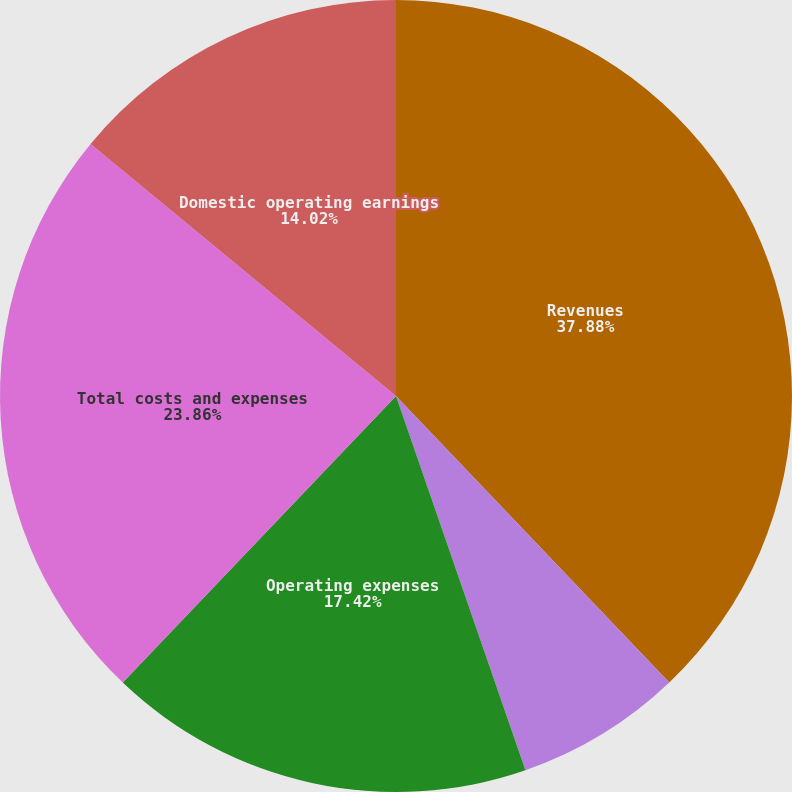Convert chart. <chart><loc_0><loc_0><loc_500><loc_500><pie_chart><fcel>Revenues<fcel>Costs of revenue<fcel>Operating expenses<fcel>Total costs and expenses<fcel>Domestic operating earnings<nl><fcel>37.88%<fcel>6.82%<fcel>17.42%<fcel>23.86%<fcel>14.02%<nl></chart> 